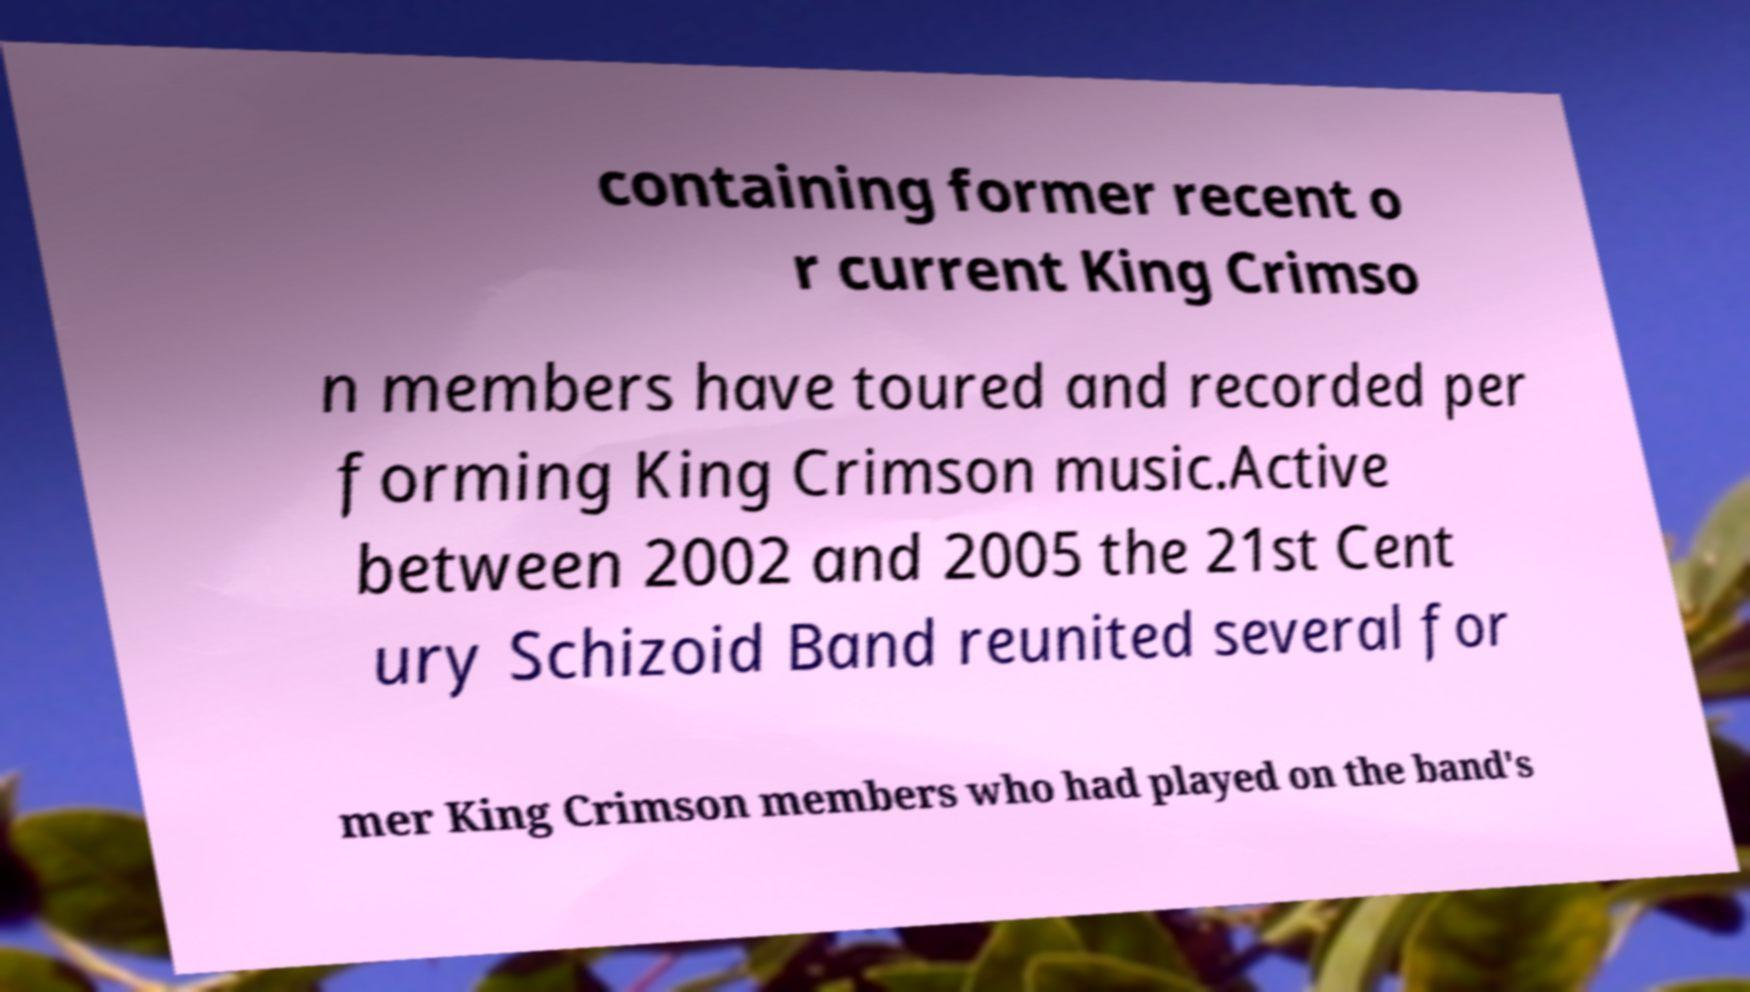For documentation purposes, I need the text within this image transcribed. Could you provide that? containing former recent o r current King Crimso n members have toured and recorded per forming King Crimson music.Active between 2002 and 2005 the 21st Cent ury Schizoid Band reunited several for mer King Crimson members who had played on the band's 